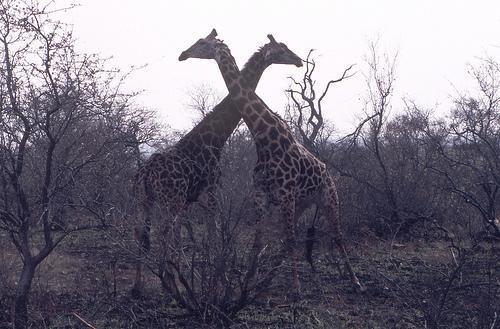How many taisl are on the right of 7 legs?
Give a very brief answer. 1. 